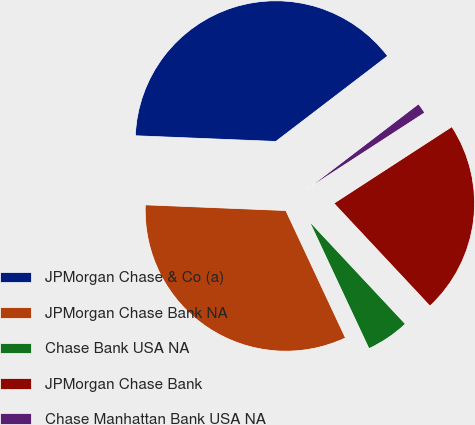<chart> <loc_0><loc_0><loc_500><loc_500><pie_chart><fcel>JPMorgan Chase & Co (a)<fcel>JPMorgan Chase Bank NA<fcel>Chase Bank USA NA<fcel>JPMorgan Chase Bank<fcel>Chase Manhattan Bank USA NA<nl><fcel>38.97%<fcel>32.62%<fcel>5.0%<fcel>22.2%<fcel>1.22%<nl></chart> 